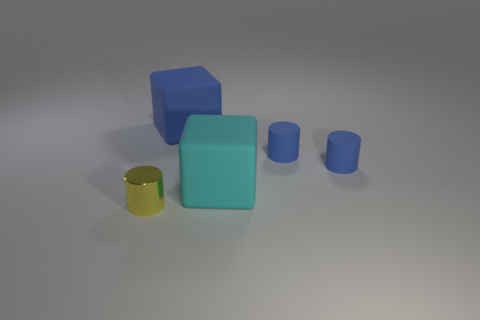The object that is to the left of the cyan matte thing and in front of the large blue matte block has what shape?
Provide a succinct answer. Cylinder. Is the number of tiny things that are in front of the small shiny object the same as the number of rubber blocks that are in front of the large blue rubber block?
Your answer should be compact. No. What number of objects are tiny yellow cylinders or large blue things?
Offer a terse response. 2. There is a rubber object that is the same size as the blue matte block; what is its color?
Provide a short and direct response. Cyan. How many objects are small cylinders behind the metal object or cubes that are behind the cyan rubber object?
Your answer should be very brief. 3. Is the number of cylinders in front of the cyan object the same as the number of big cyan blocks?
Your response must be concise. Yes. There is a thing left of the blue matte cube; is it the same size as the block in front of the blue block?
Ensure brevity in your answer.  No. How many other objects are the same size as the cyan object?
Offer a very short reply. 1. There is a block that is in front of the matte cube behind the cyan matte cube; are there any things that are in front of it?
Provide a succinct answer. Yes. Is there anything else that has the same color as the shiny cylinder?
Your response must be concise. No. 